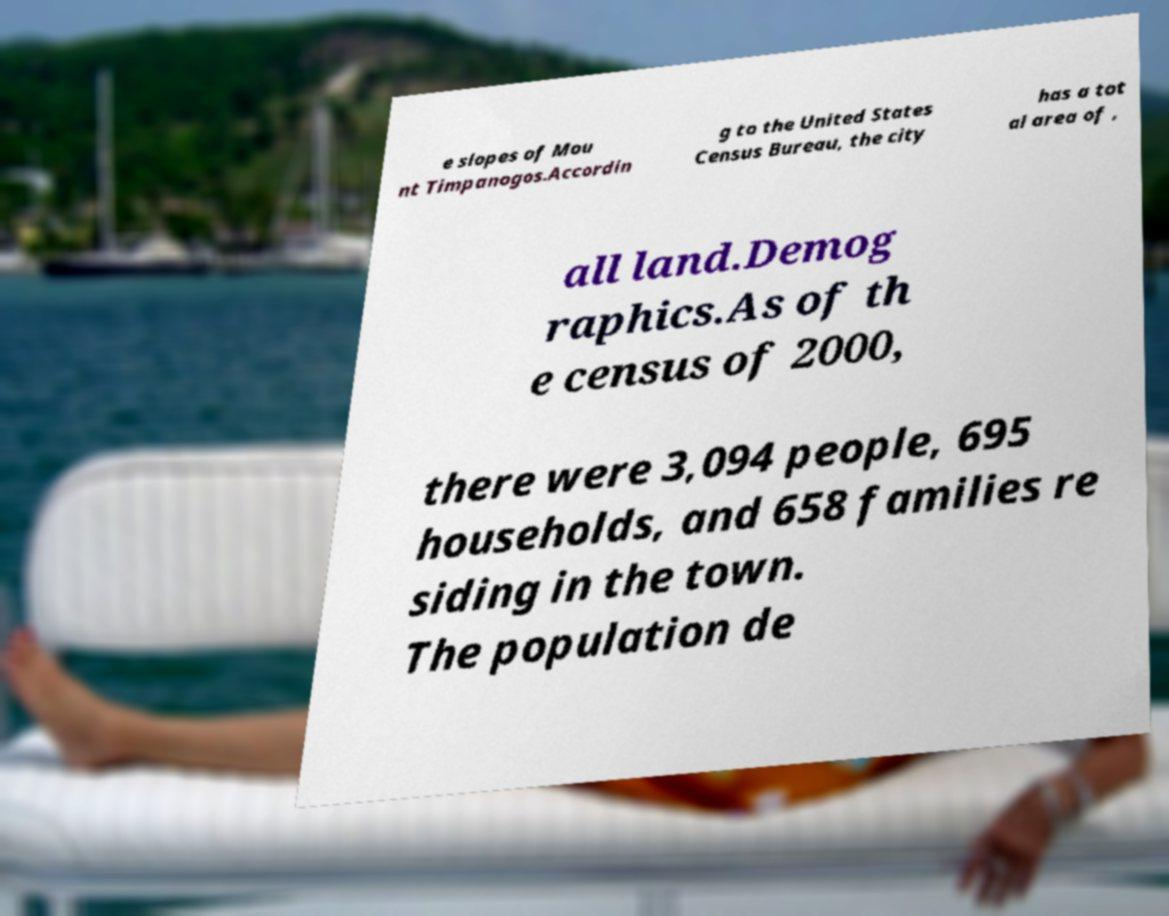I need the written content from this picture converted into text. Can you do that? e slopes of Mou nt Timpanogos.Accordin g to the United States Census Bureau, the city has a tot al area of , all land.Demog raphics.As of th e census of 2000, there were 3,094 people, 695 households, and 658 families re siding in the town. The population de 